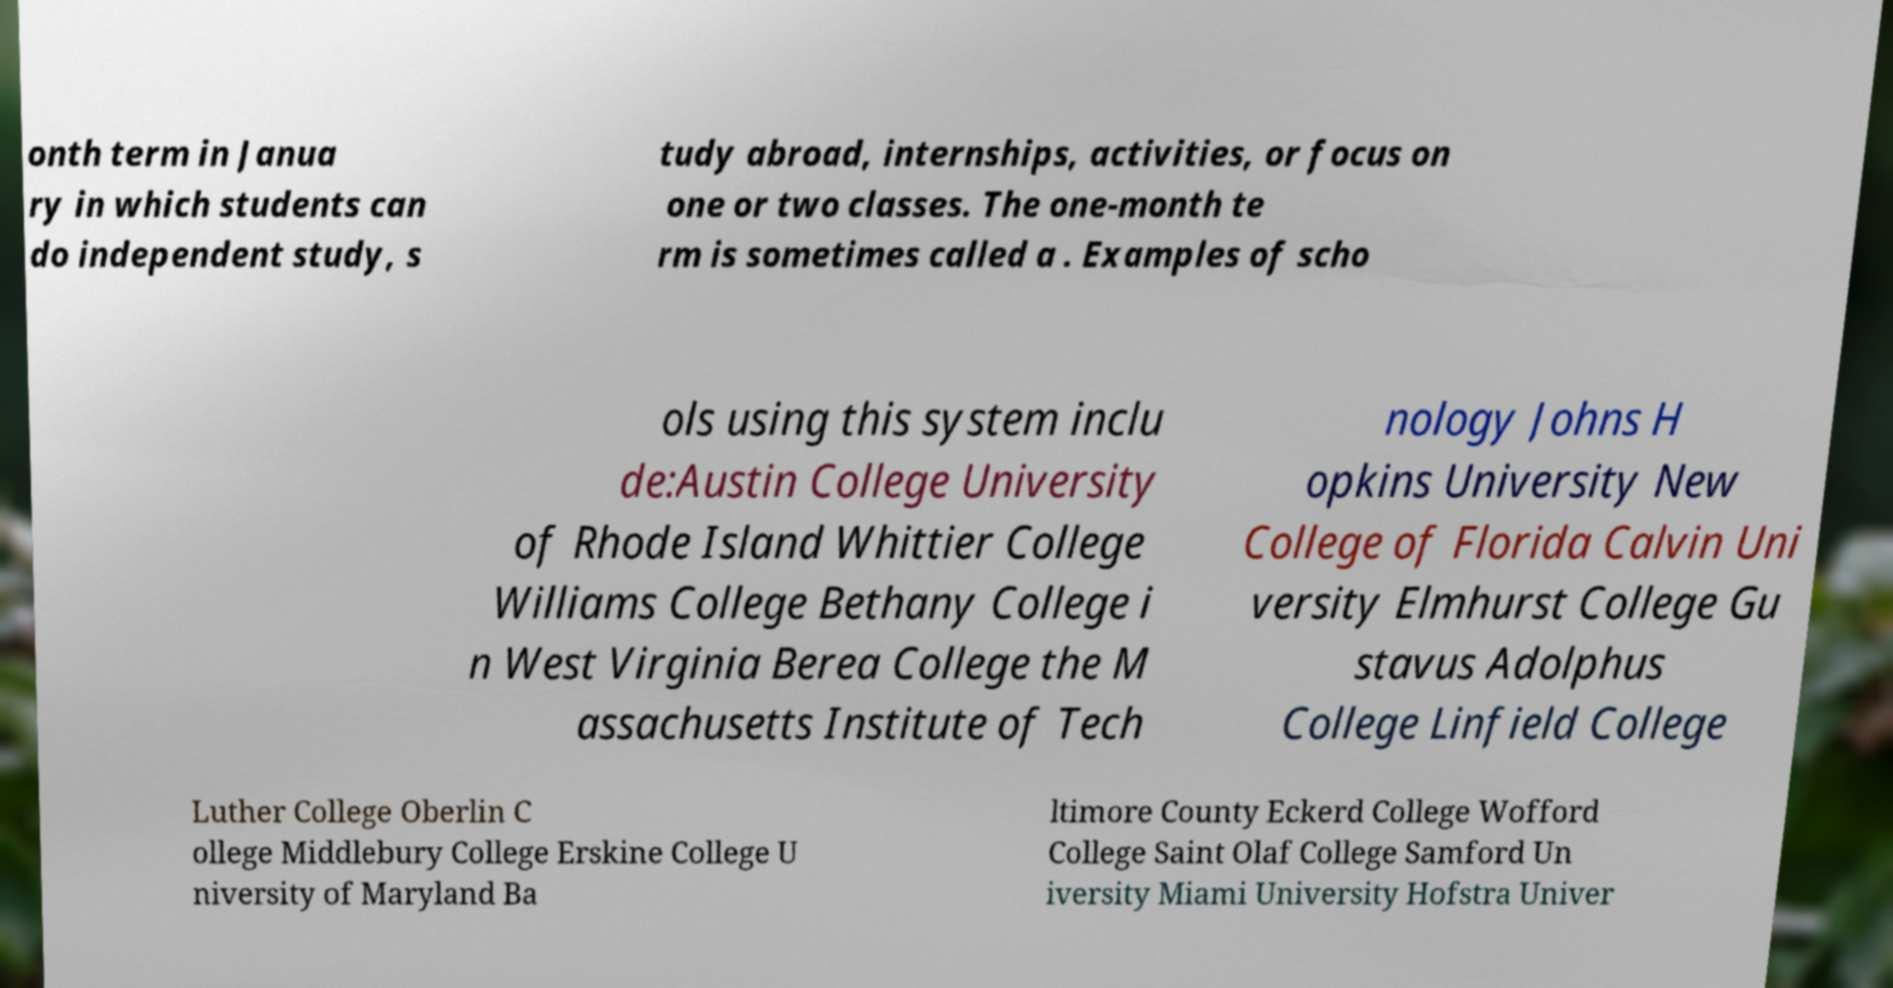Can you accurately transcribe the text from the provided image for me? onth term in Janua ry in which students can do independent study, s tudy abroad, internships, activities, or focus on one or two classes. The one-month te rm is sometimes called a . Examples of scho ols using this system inclu de:Austin College University of Rhode Island Whittier College Williams College Bethany College i n West Virginia Berea College the M assachusetts Institute of Tech nology Johns H opkins University New College of Florida Calvin Uni versity Elmhurst College Gu stavus Adolphus College Linfield College Luther College Oberlin C ollege Middlebury College Erskine College U niversity of Maryland Ba ltimore County Eckerd College Wofford College Saint Olaf College Samford Un iversity Miami University Hofstra Univer 